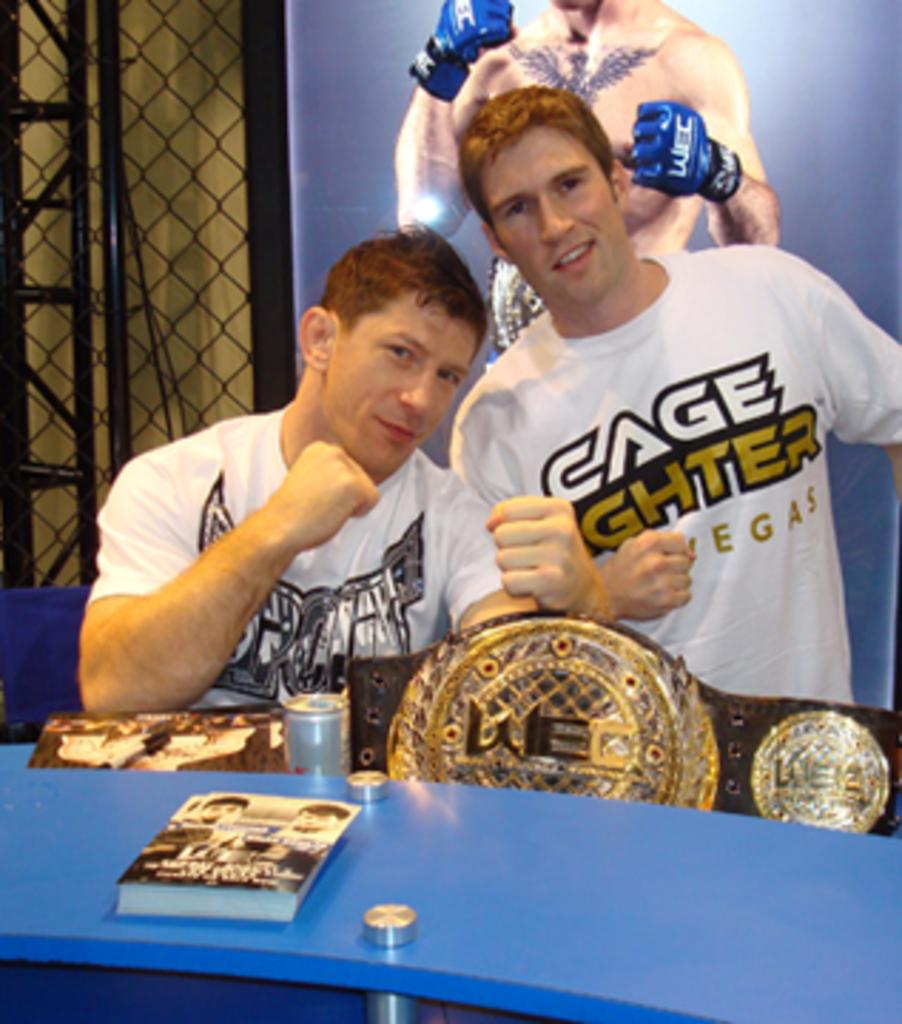How many people are in the image? There are two persons in the image. What is in front of the persons? There is a book in front of the persons. What color is the surface on which the objects are placed? The surface is blue. What can be seen in the background of the image? There is a board and a railing in the background of the image. What type of feeling can be seen on the faces of the persons in the image? The provided facts do not mention any specific feelings or expressions on the faces of the persons in the image. 